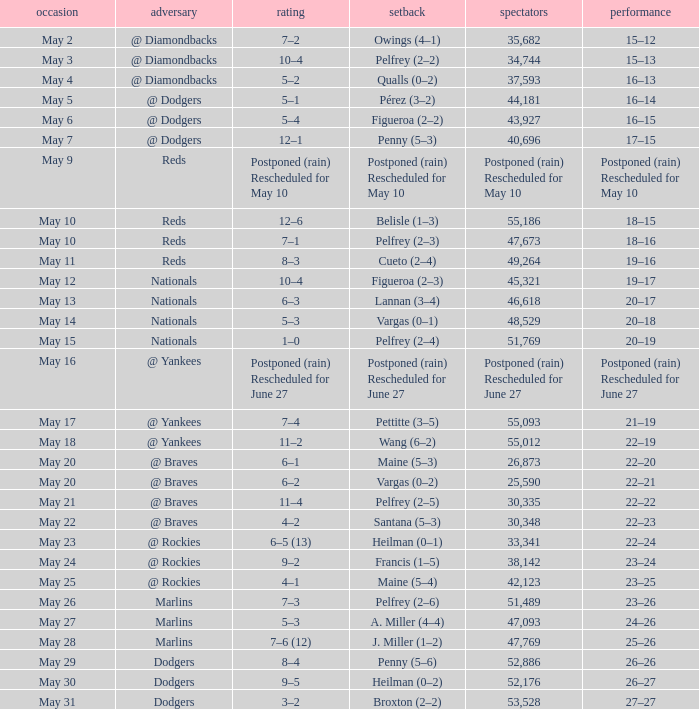Regarding the 22-20 record, what was the score? 6–1. 